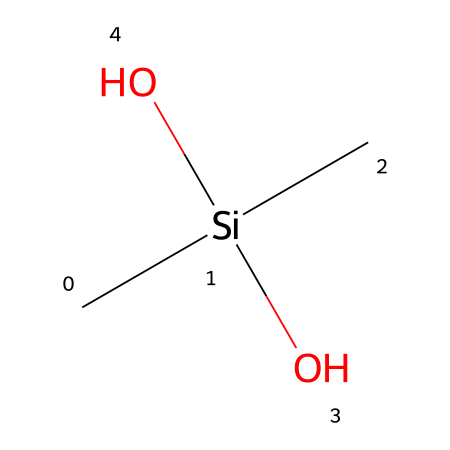what is the name of this chemical? The SMILES representation "C[Si](C)(O)O" indicates the chemical structure, which corresponds to dimethylsilanediol where two methyl groups are attached to a silicon atom and hydroxyl groups are present.
Answer: dimethylsilanediol how many carbon atoms are in this chemical? In the SMILES "C[Si](C)(O)O", there are two "C" symbols representing carbon atoms in the structure.
Answer: 2 what functional groups are present in this chemical? The structure contains hydroxyl groups, indicated by "(O)O" in the SMILES notation which shows the presence of alcohol functional groups.
Answer: hydroxyl how many hydrogen atoms are associated with silicon in this chemical? In this structure, there are no hydrogen atoms explicitly shown bonded to the silicon atom since it forms bonds with the two carbon atoms and two hydroxyl groups, leading to it having no remaining valence for hydrogen.
Answer: 0 what type of compound is dimethylsilanediol categorized as? Dimethylsilanediol is categorized as a silanol because it contains a silicon atom bonded to hydroxyl groups, defining it as a silicon-containing alcohol.
Answer: silanol how many oxygen atoms are in this chemical? The SMILES "C[Si](C)(O)O" includes two "O" symbols representing two oxygen atoms in the structure.
Answer: 2 what is the main characteristic that distinguishes silanes from other organic compounds? Silanes are distinct because they contain silicon atoms bonded to carbon and/or hydrogen atoms, which is a key feature observed in the given SMILES structure.
Answer: silicon atom 